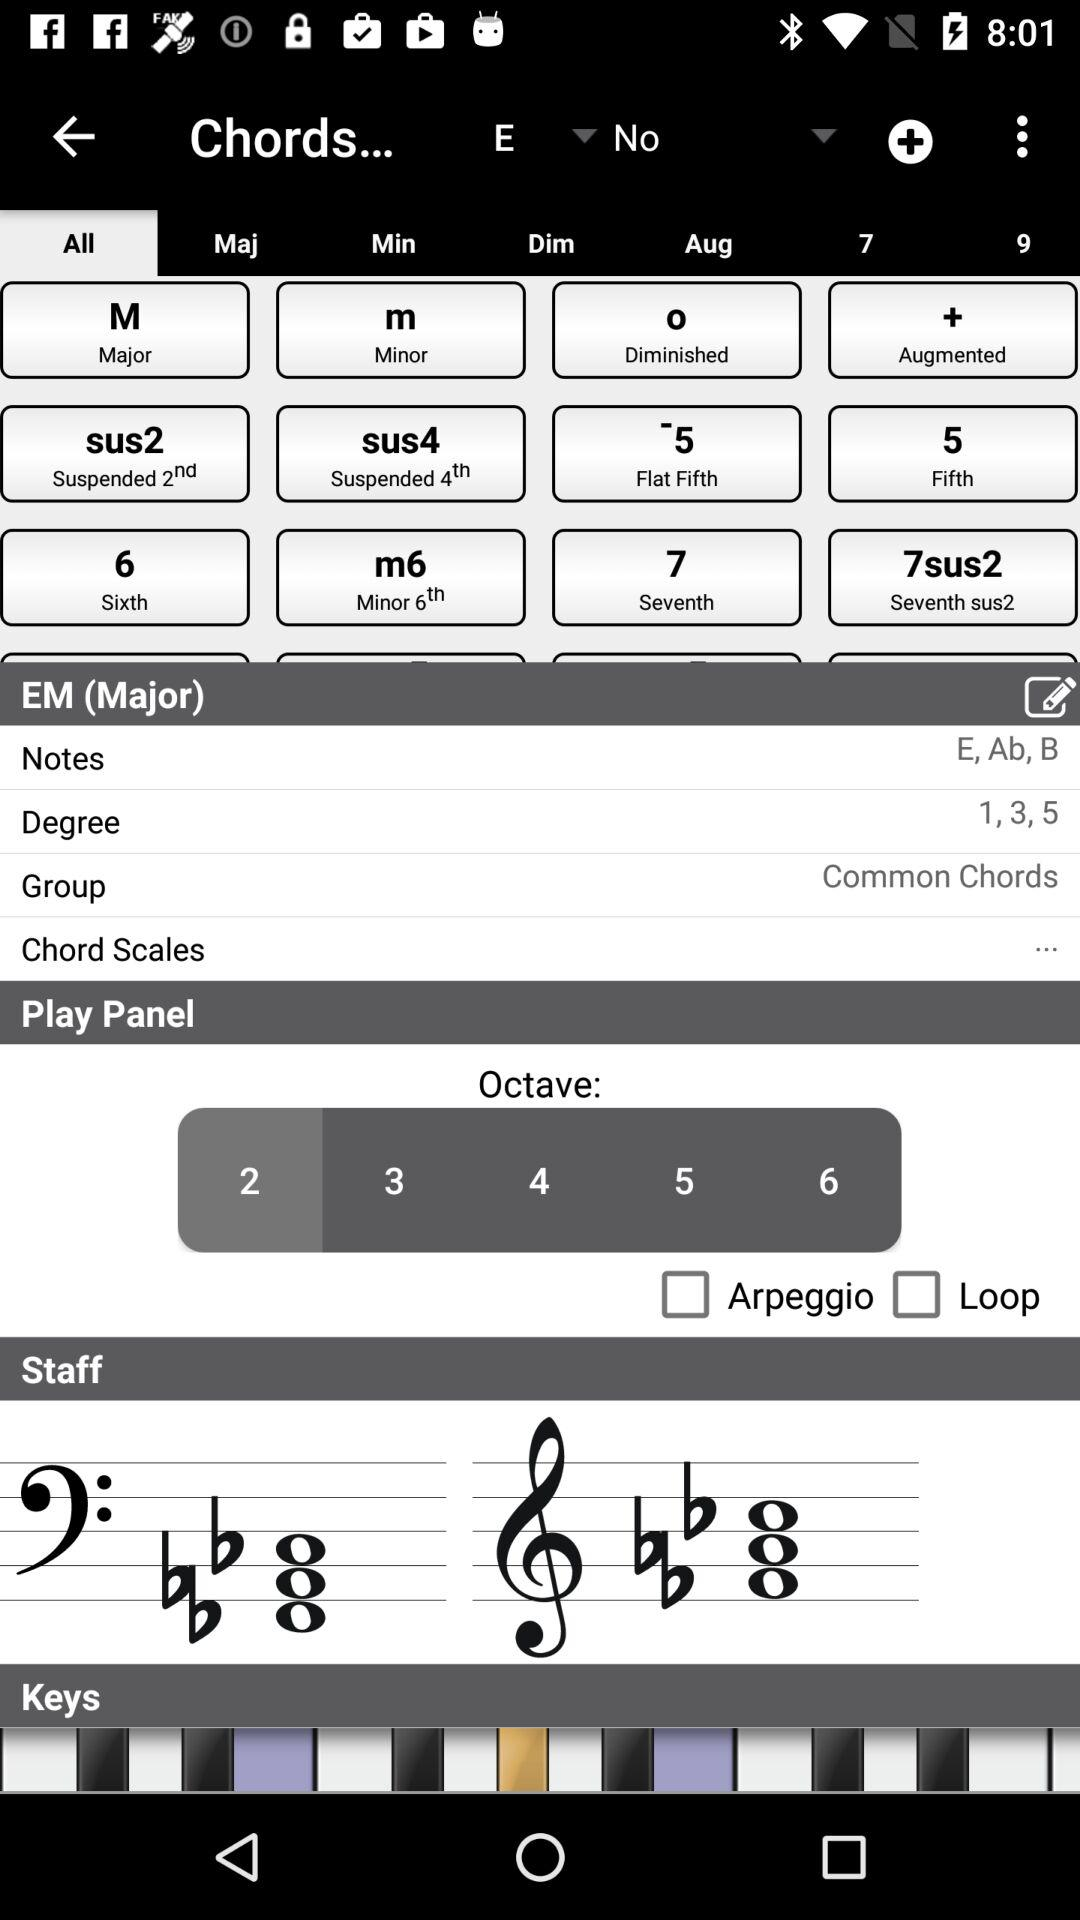Which tab is selected? The selected tab is "All". 